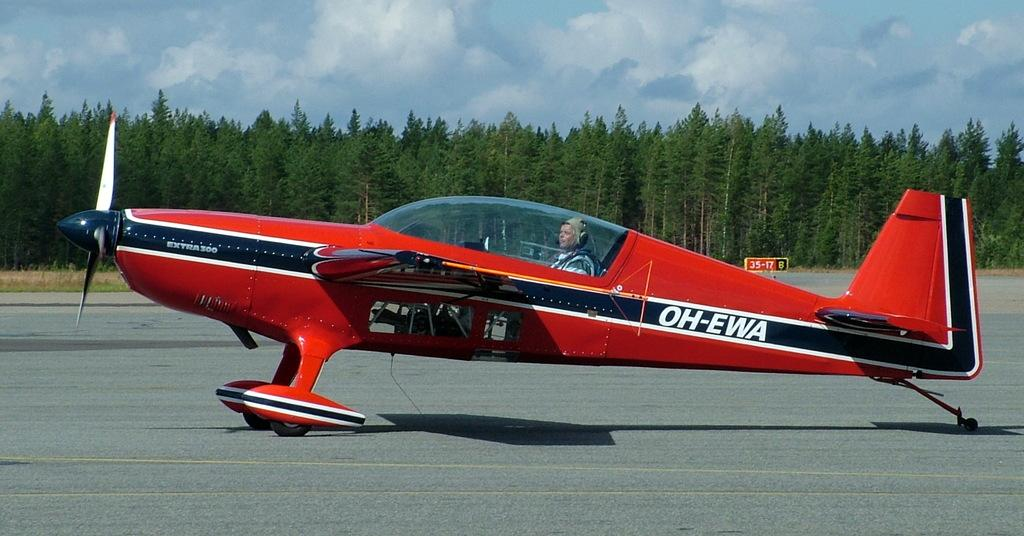<image>
Offer a succinct explanation of the picture presented. a red black and white airplane with the text oh-ewa on the back. 